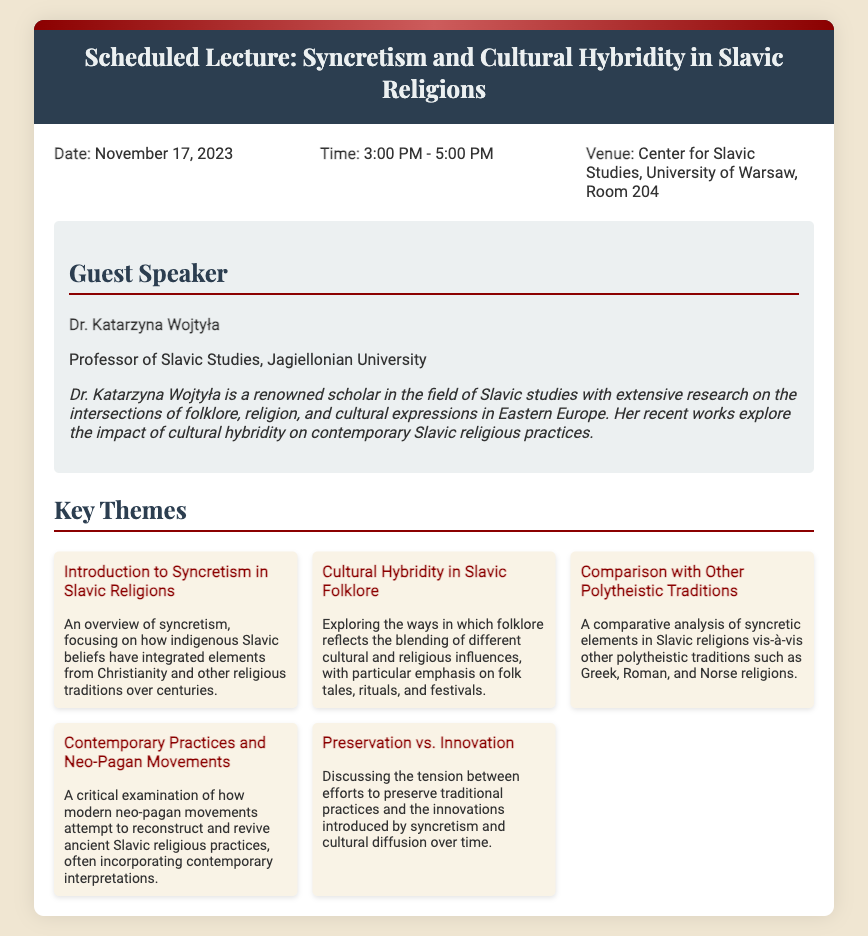What is the date of the lecture? The date is explicitly mentioned in the document as November 17, 2023.
Answer: November 17, 2023 What time does the lecture start? The starting time is given in the document as 3:00 PM.
Answer: 3:00 PM Where is the lecture being held? The venue details are provided as Center for Slavic Studies, University of Warsaw, Room 204.
Answer: Center for Slavic Studies, University of Warsaw, Room 204 Who is the guest speaker? The document identifies the guest speaker as Dr. Katarzyna Wojtyła.
Answer: Dr. Katarzyna Wojtyła What is Dr. Wojtyła's position? The document states that Dr. Wojtyła is a Professor of Slavic Studies.
Answer: Professor of Slavic Studies What is one of the key themes discussed in the lecture? The themes are listed, and one of them is "Introduction to Syncretism in Slavic Religions."
Answer: Introduction to Syncretism in Slavic Religions How long is the lecture scheduled to last? The duration of the lecture is implied by the start and end times, which are 3:00 PM to 5:00 PM, totaling 2 hours.
Answer: 2 hours What is a theme related to modern practices mentioned in the lecture? One of the themes addresses contemporary practices, particularly "Contemporary Practices and Neo-Pagan Movements."
Answer: Contemporary Practices and Neo-Pagan Movements Which cultural aspect is compared with Slavic religions in the lecture? The document indicates that a comparison will be made with other polytheistic traditions.
Answer: Other polytheistic traditions 